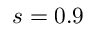Convert formula to latex. <formula><loc_0><loc_0><loc_500><loc_500>s = 0 . 9</formula> 